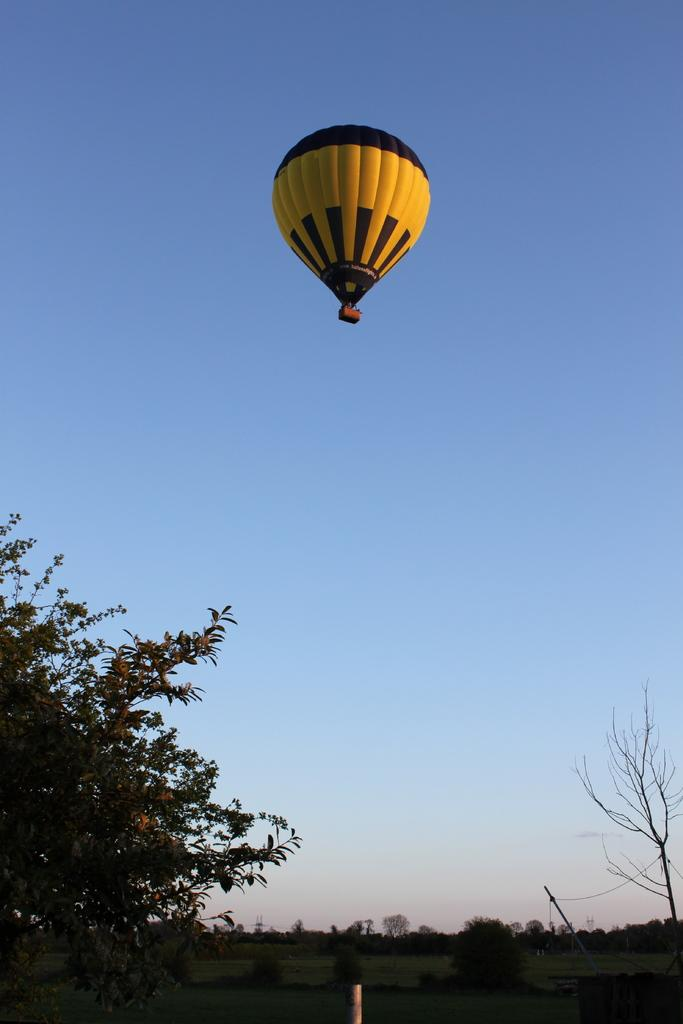What type of vegetation is at the bottom of the image? There are trees at the bottom of the image. What object is also present at the bottom of the image? There is a pole at the bottom of the image. What is visible at the top of the image? There is a parachute at the top of the image. What else can be seen in the sky at the top of the image? The sky is visible at the top of the image. Can you see a rabbit hopping around in the prison at the bottom of the image? There is no rabbit or prison present in the image. The image features trees and a pole at the bottom, and a parachute and sky at the top. 